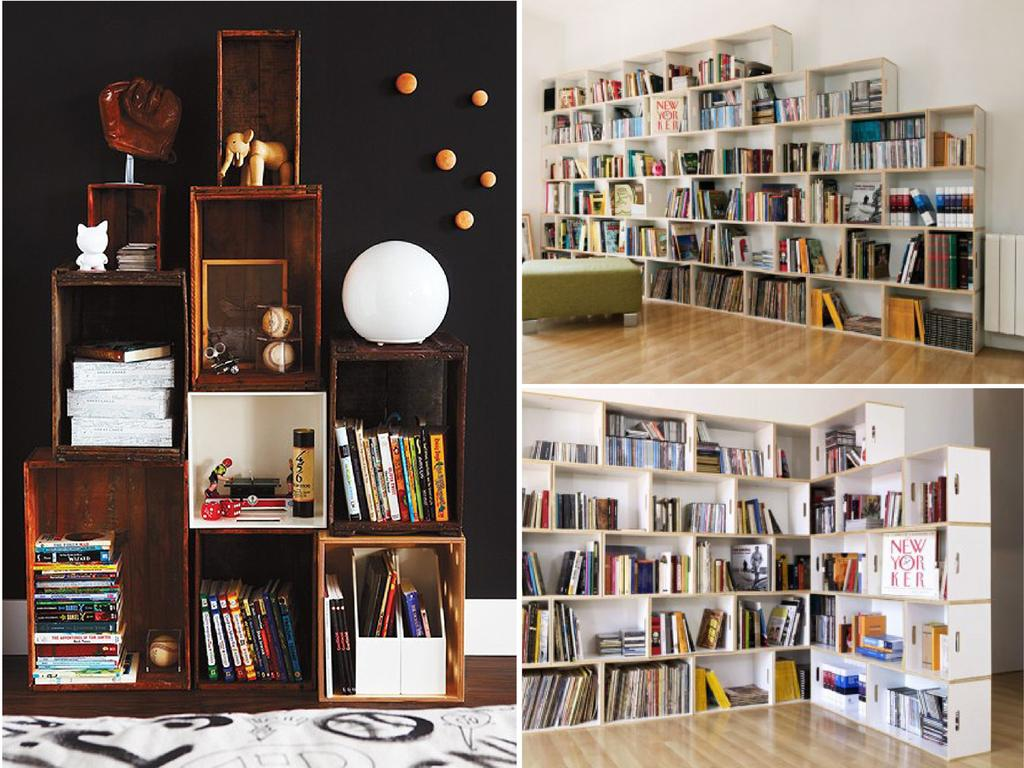What type of photograph is depicted in the image? The image contains a college photograph. What can be seen on the wooden racks in the photograph? There are wooden racks full of books in the photograph. Can you describe the color of one of the book racks? There is a brown color rack with books. What type of light source is visible in the photograph? There is a white color round light on the left side of the photograph. How many hills can be seen in the background of the photograph? There are no hills visible in the background of the photograph; it features a college setting with wooden racks full of books. What type of yarn is being used to hold the books together in the photograph? There is no yarn present in the photograph; the books are placed on wooden racks. 